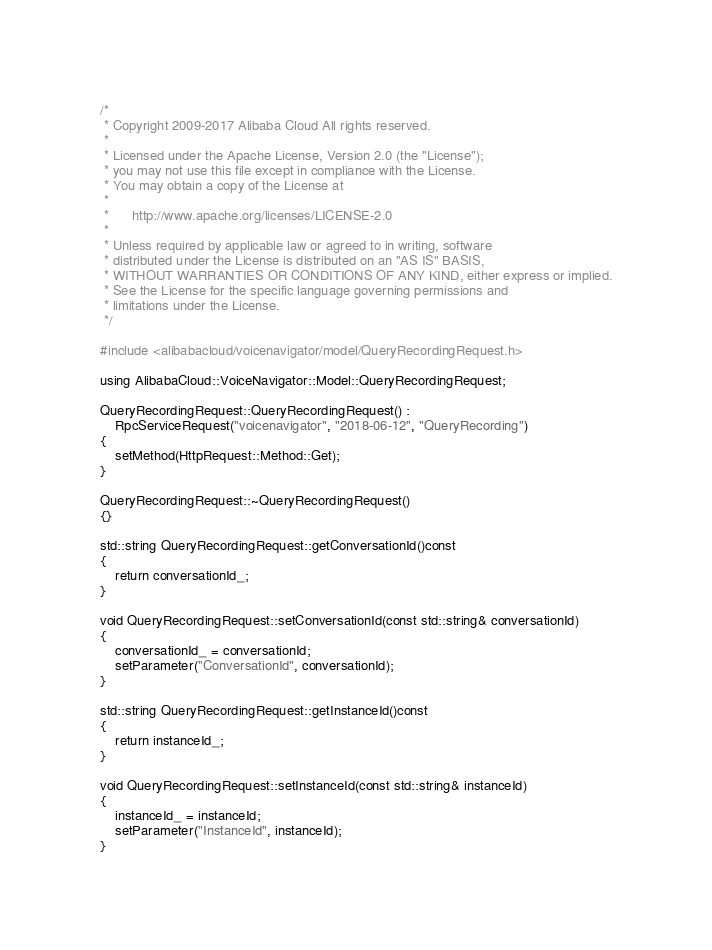Convert code to text. <code><loc_0><loc_0><loc_500><loc_500><_C++_>/*
 * Copyright 2009-2017 Alibaba Cloud All rights reserved.
 * 
 * Licensed under the Apache License, Version 2.0 (the "License");
 * you may not use this file except in compliance with the License.
 * You may obtain a copy of the License at
 * 
 *      http://www.apache.org/licenses/LICENSE-2.0
 * 
 * Unless required by applicable law or agreed to in writing, software
 * distributed under the License is distributed on an "AS IS" BASIS,
 * WITHOUT WARRANTIES OR CONDITIONS OF ANY KIND, either express or implied.
 * See the License for the specific language governing permissions and
 * limitations under the License.
 */

#include <alibabacloud/voicenavigator/model/QueryRecordingRequest.h>

using AlibabaCloud::VoiceNavigator::Model::QueryRecordingRequest;

QueryRecordingRequest::QueryRecordingRequest() :
	RpcServiceRequest("voicenavigator", "2018-06-12", "QueryRecording")
{
	setMethod(HttpRequest::Method::Get);
}

QueryRecordingRequest::~QueryRecordingRequest()
{}

std::string QueryRecordingRequest::getConversationId()const
{
	return conversationId_;
}

void QueryRecordingRequest::setConversationId(const std::string& conversationId)
{
	conversationId_ = conversationId;
	setParameter("ConversationId", conversationId);
}

std::string QueryRecordingRequest::getInstanceId()const
{
	return instanceId_;
}

void QueryRecordingRequest::setInstanceId(const std::string& instanceId)
{
	instanceId_ = instanceId;
	setParameter("InstanceId", instanceId);
}

</code> 